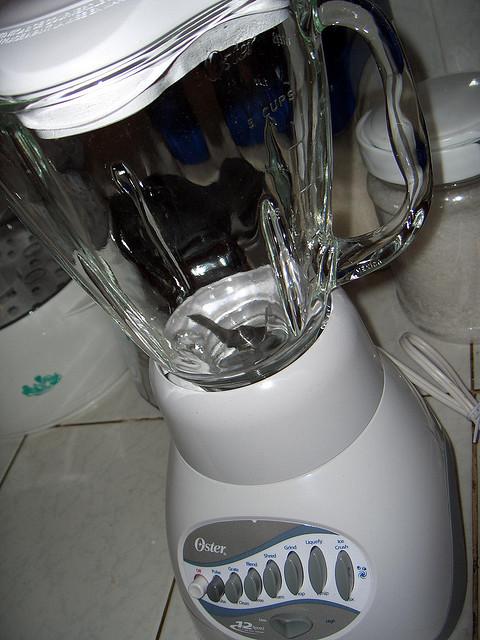Is there anything in the jar?
Answer briefly. No. Is this a kitchen appliance?
Keep it brief. Yes. What is in the reflection of the vases?
Concise answer only. Light. How makes this blender?
Short answer required. Oster. 